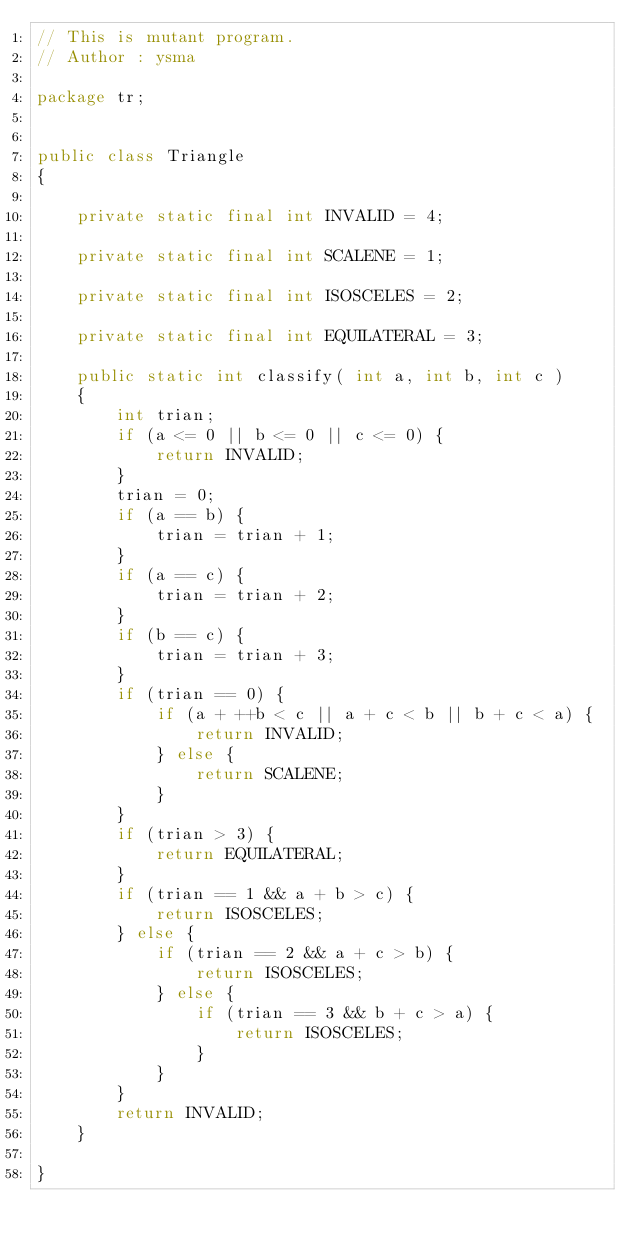Convert code to text. <code><loc_0><loc_0><loc_500><loc_500><_Java_>// This is mutant program.
// Author : ysma

package tr;


public class Triangle
{

    private static final int INVALID = 4;

    private static final int SCALENE = 1;

    private static final int ISOSCELES = 2;

    private static final int EQUILATERAL = 3;

    public static int classify( int a, int b, int c )
    {
        int trian;
        if (a <= 0 || b <= 0 || c <= 0) {
            return INVALID;
        }
        trian = 0;
        if (a == b) {
            trian = trian + 1;
        }
        if (a == c) {
            trian = trian + 2;
        }
        if (b == c) {
            trian = trian + 3;
        }
        if (trian == 0) {
            if (a + ++b < c || a + c < b || b + c < a) {
                return INVALID;
            } else {
                return SCALENE;
            }
        }
        if (trian > 3) {
            return EQUILATERAL;
        }
        if (trian == 1 && a + b > c) {
            return ISOSCELES;
        } else {
            if (trian == 2 && a + c > b) {
                return ISOSCELES;
            } else {
                if (trian == 3 && b + c > a) {
                    return ISOSCELES;
                }
            }
        }
        return INVALID;
    }

}
</code> 